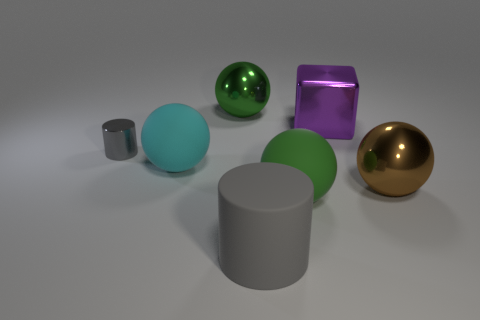Subtract all blue spheres. Subtract all brown cylinders. How many spheres are left? 4 Add 1 big brown shiny objects. How many objects exist? 8 Subtract all blocks. How many objects are left? 6 Add 3 small gray balls. How many small gray balls exist? 3 Subtract 0 purple spheres. How many objects are left? 7 Subtract all tiny gray shiny objects. Subtract all purple metal blocks. How many objects are left? 5 Add 1 large gray cylinders. How many large gray cylinders are left? 2 